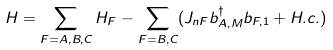Convert formula to latex. <formula><loc_0><loc_0><loc_500><loc_500>H = \sum _ { F = A , B , C } H _ { F } - \sum _ { F = B , C } ( J _ { n F } b _ { A , M } ^ { \dag } b _ { F , 1 } + H . c . )</formula> 